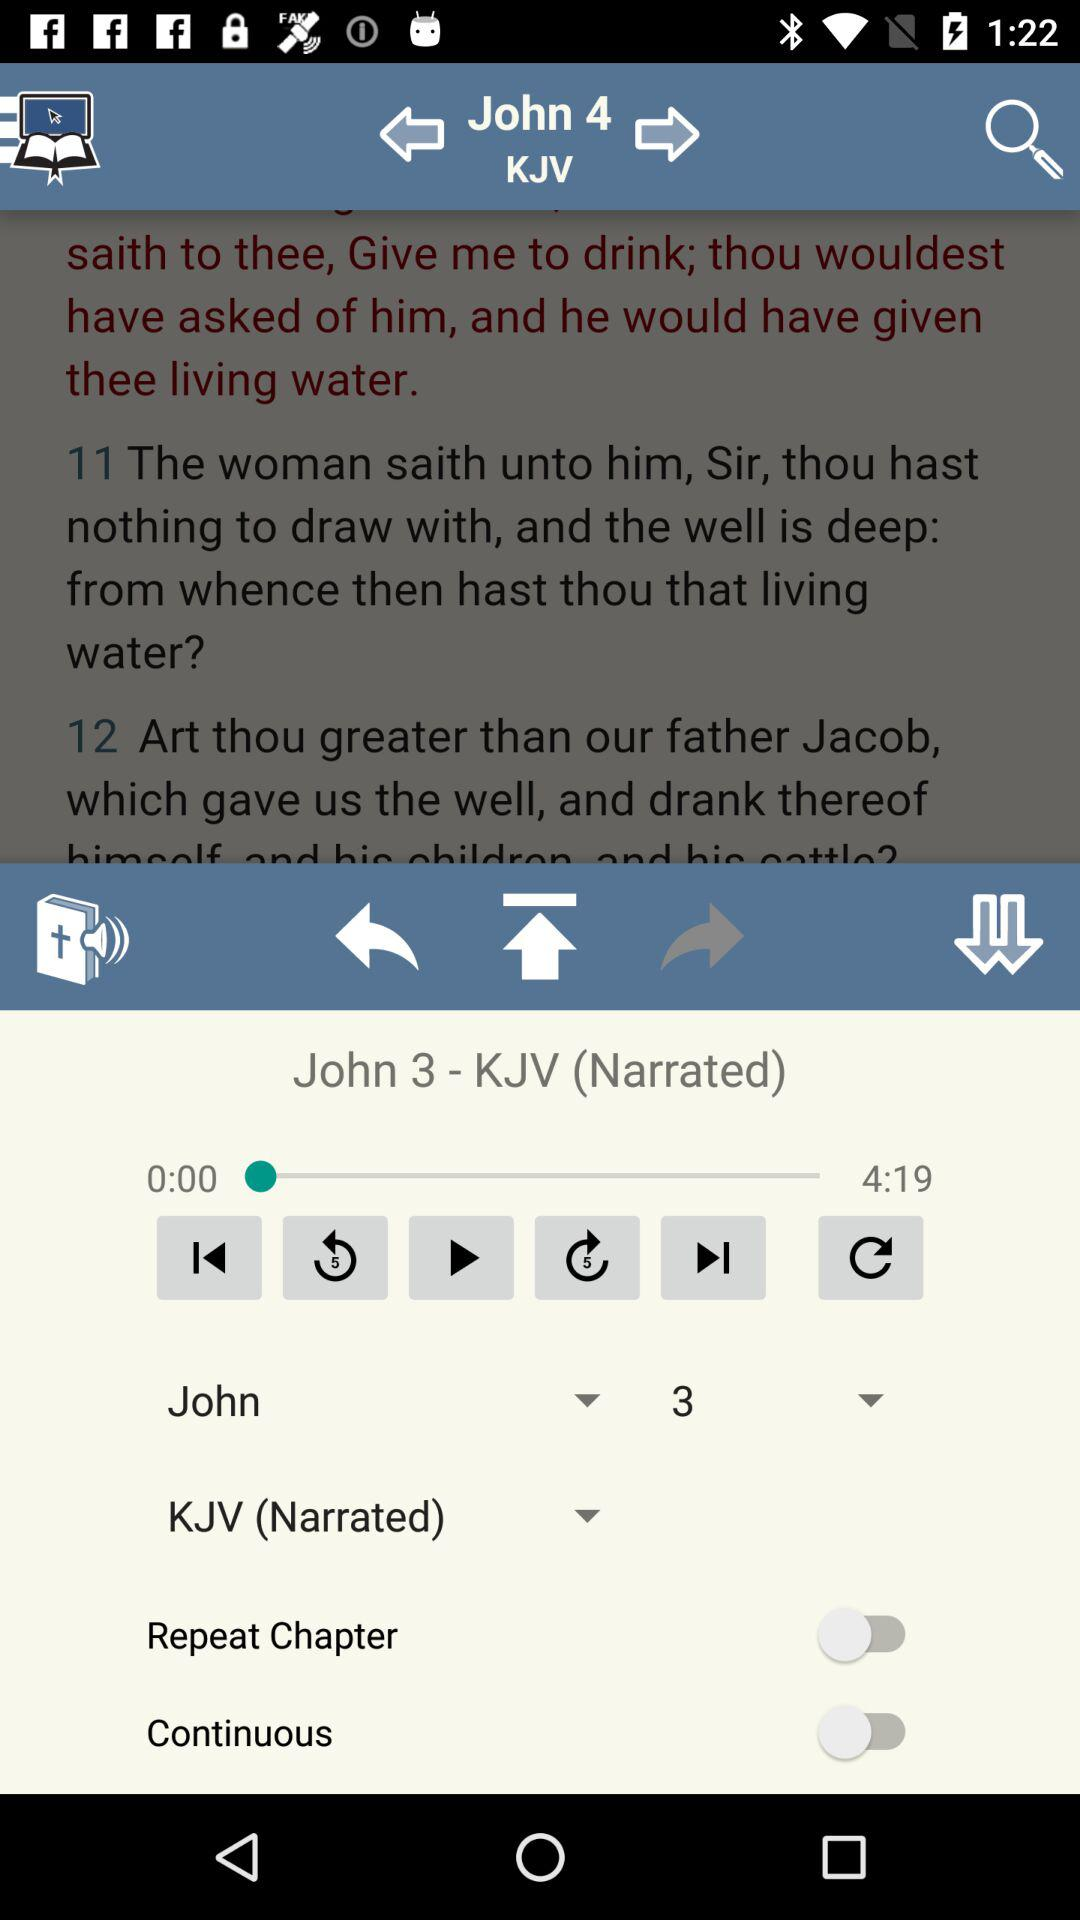What is the time duration of "John 3 - KJV (Narrated)"? The time duration of "John 3 - KJV (Narrated)" is 4 minutes 19 seconds. 